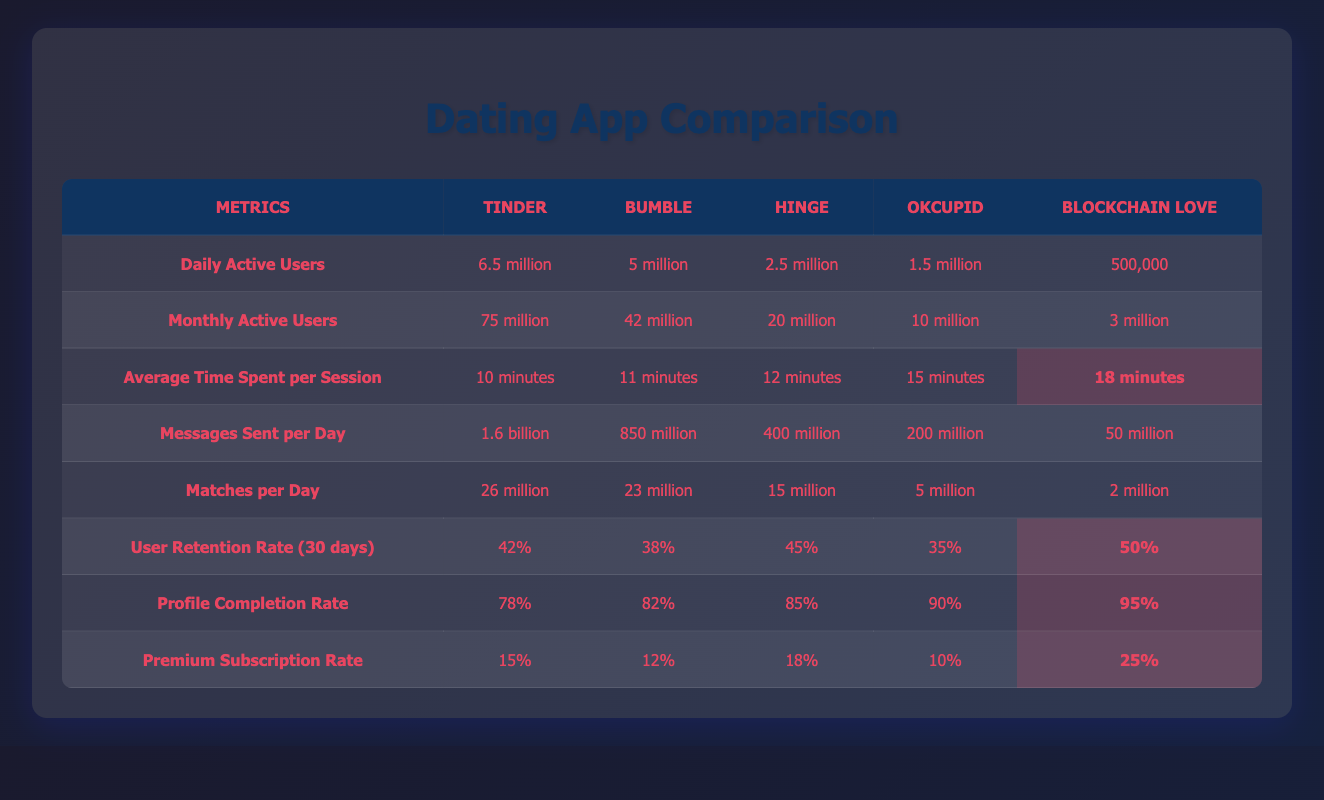What is the Daily Active Users count for Tinder? The Daily Active Users for Tinder is shown directly in the table as 6.5 million.
Answer: 6.5 million Which app has the highest User Retention Rate (30 days)? In the table, Blockchain Love has the highest User Retention Rate at 50%, compared to the others.
Answer: Blockchain Love What is the difference in Monthly Active Users between Hinge and OkCupid? Hinge has 20 million Monthly Active Users and OkCupid has 10 million. The difference is calculated as 20 million - 10 million = 10 million.
Answer: 10 million Is the Average Time Spent per Session on Bumble greater than that of Tinder? From the table, Bumble has an average time of 11 minutes, while Tinder has 10 minutes. Since 11 is greater than 10, the answer is yes.
Answer: Yes How many total Messages Sent per Day are reported for all apps combined? The total Messages Sent per Day is calculated by adding the figures for all apps: 1.6 billion + 850 million + 400 million + 200 million + 50 million = 3.1 billion.
Answer: 3.1 billion Which app has the lowest Profile Completion Rate? The Profile Completion Rate for OkCupid is 90%, which is the lowest compared to the others listed.
Answer: OkCupid If all apps are compared, which one has the longest Average Time Spent per Session? The Average Time Spent per Session for Blockchain Love is 18 minutes, which is the highest compared to all other apps. This can be verified by looking at the relevant row in the table.
Answer: Blockchain Love What is the ratio of Premium Subscription Rate for Blockchain Love to Bumble? The Premium Subscription Rate for Blockchain Love is 25% and for Bumble is 12%. The ratio is calculated as 25% / 12% = approximately 2.08.
Answer: Approximately 2.08 Which app sends more matches daily, Tinder or Hinge? Tinder sends 26 million matches per day while Hinge sends 15 million matches per day. Since 26 is greater than 15, Tinder sends more matches daily.
Answer: Tinder 